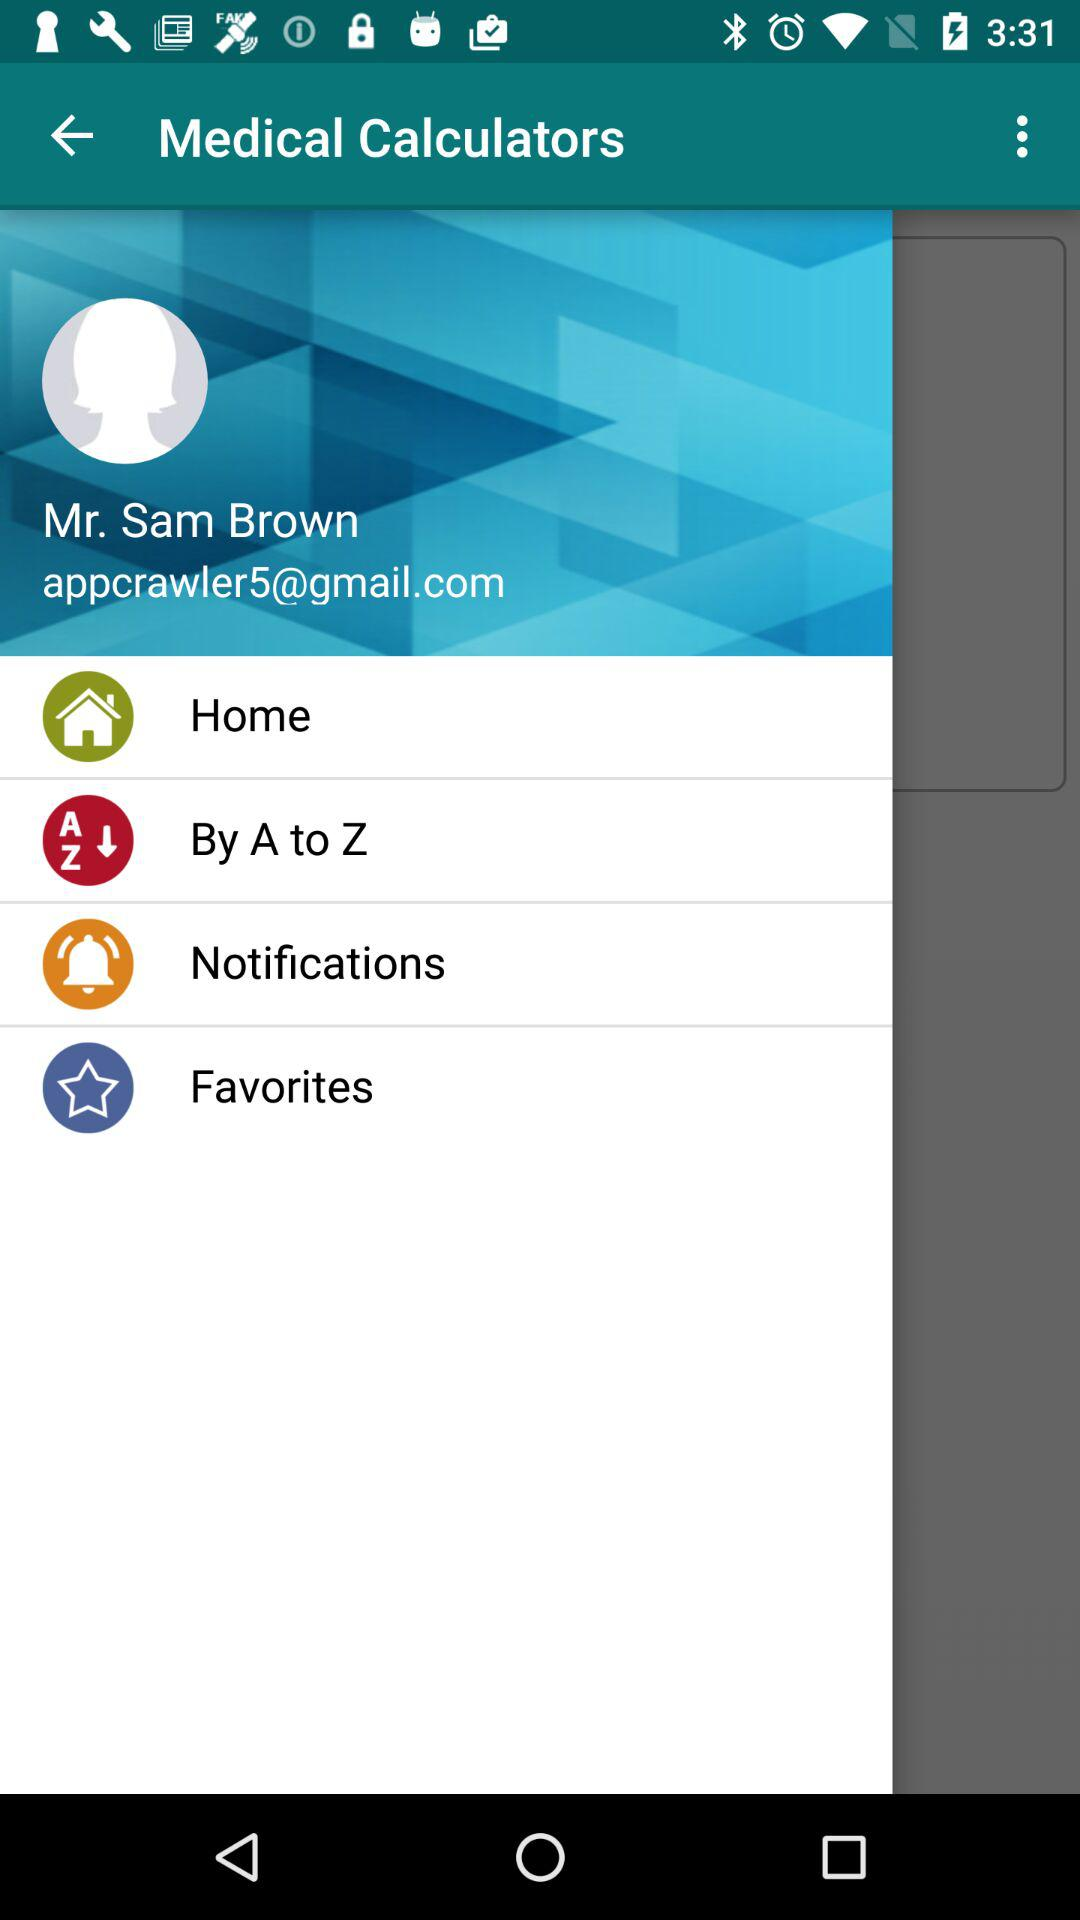What is the email address? The email address is appcrawler5@gmail.com. 